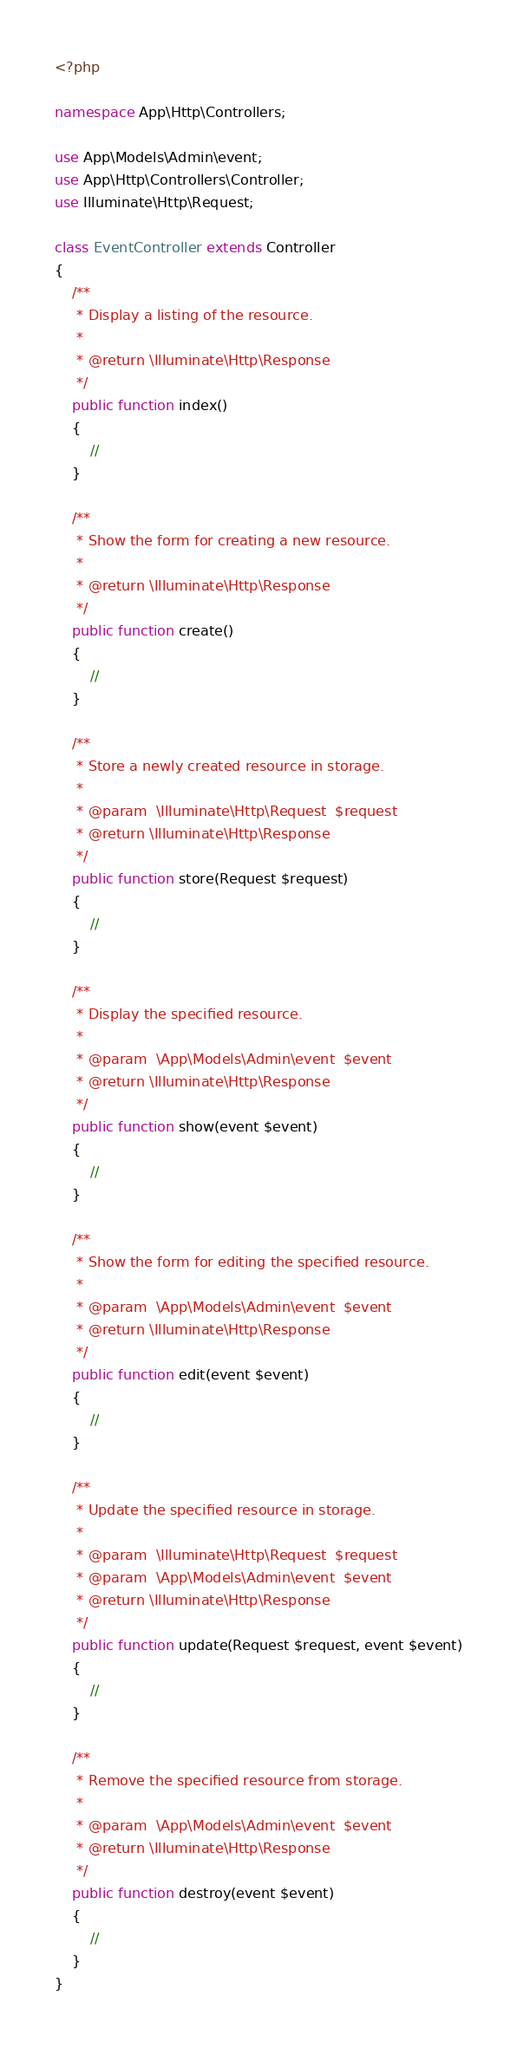Convert code to text. <code><loc_0><loc_0><loc_500><loc_500><_PHP_><?php

namespace App\Http\Controllers;

use App\Models\Admin\event;
use App\Http\Controllers\Controller;
use Illuminate\Http\Request;

class EventController extends Controller
{
    /**
     * Display a listing of the resource.
     *
     * @return \Illuminate\Http\Response
     */
    public function index()
    {
        //
    }

    /**
     * Show the form for creating a new resource.
     *
     * @return \Illuminate\Http\Response
     */
    public function create()
    {
        //
    }

    /**
     * Store a newly created resource in storage.
     *
     * @param  \Illuminate\Http\Request  $request
     * @return \Illuminate\Http\Response
     */
    public function store(Request $request)
    {
        //
    }

    /**
     * Display the specified resource.
     *
     * @param  \App\Models\Admin\event  $event
     * @return \Illuminate\Http\Response
     */
    public function show(event $event)
    {
        //
    }

    /**
     * Show the form for editing the specified resource.
     *
     * @param  \App\Models\Admin\event  $event
     * @return \Illuminate\Http\Response
     */
    public function edit(event $event)
    {
        //
    }

    /**
     * Update the specified resource in storage.
     *
     * @param  \Illuminate\Http\Request  $request
     * @param  \App\Models\Admin\event  $event
     * @return \Illuminate\Http\Response
     */
    public function update(Request $request, event $event)
    {
        //
    }

    /**
     * Remove the specified resource from storage.
     *
     * @param  \App\Models\Admin\event  $event
     * @return \Illuminate\Http\Response
     */
    public function destroy(event $event)
    {
        //
    }
}
</code> 